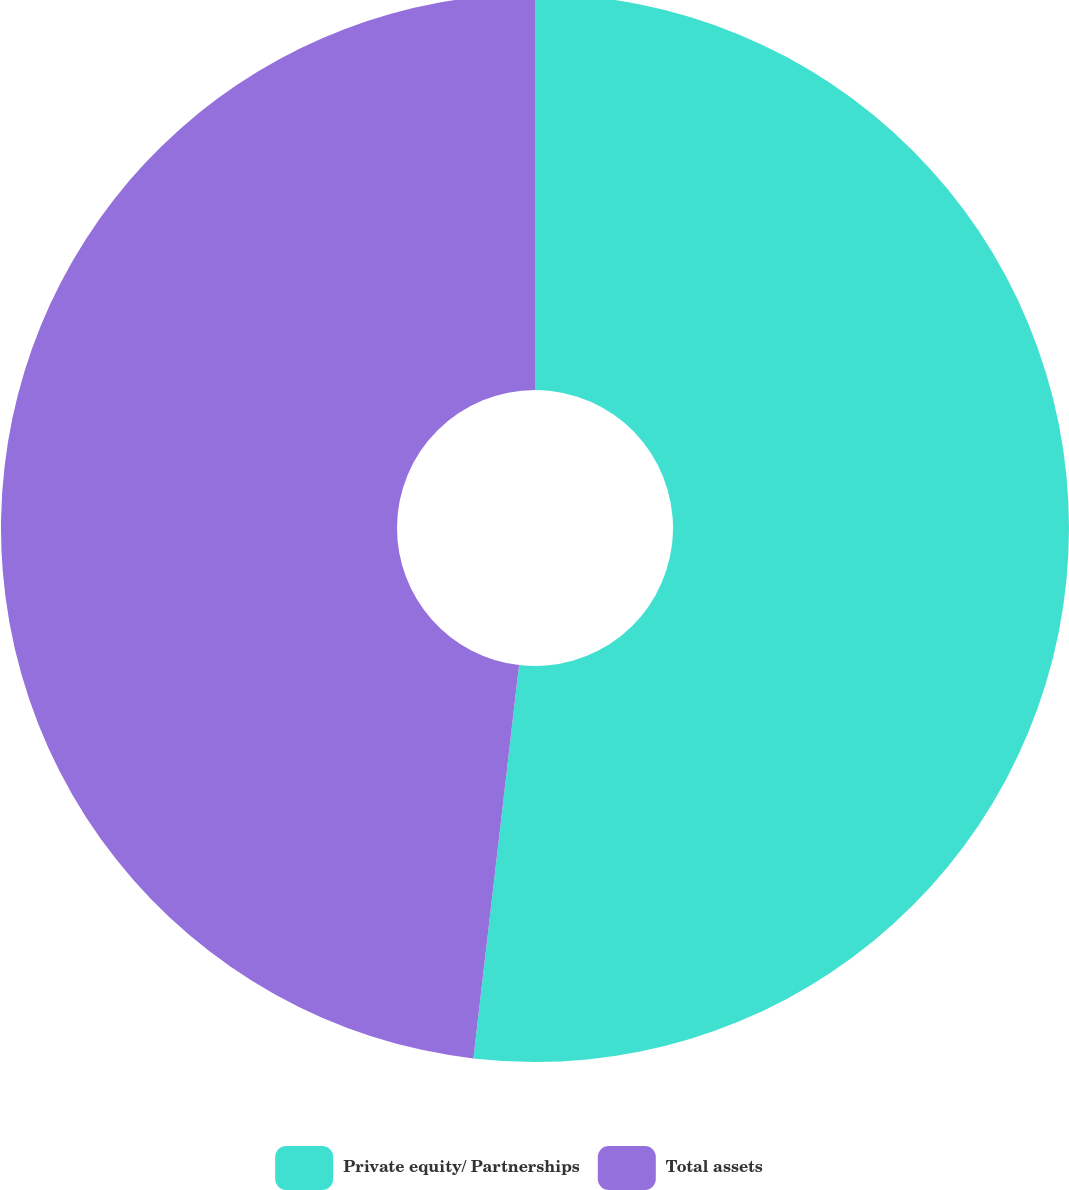<chart> <loc_0><loc_0><loc_500><loc_500><pie_chart><fcel>Private equity/ Partnerships<fcel>Total assets<nl><fcel>51.84%<fcel>48.16%<nl></chart> 